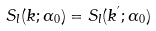<formula> <loc_0><loc_0><loc_500><loc_500>S _ { l } ( k ; \alpha _ { 0 } ) = S _ { l } ( k ^ { ^ { \prime } } ; \alpha _ { 0 } )</formula> 